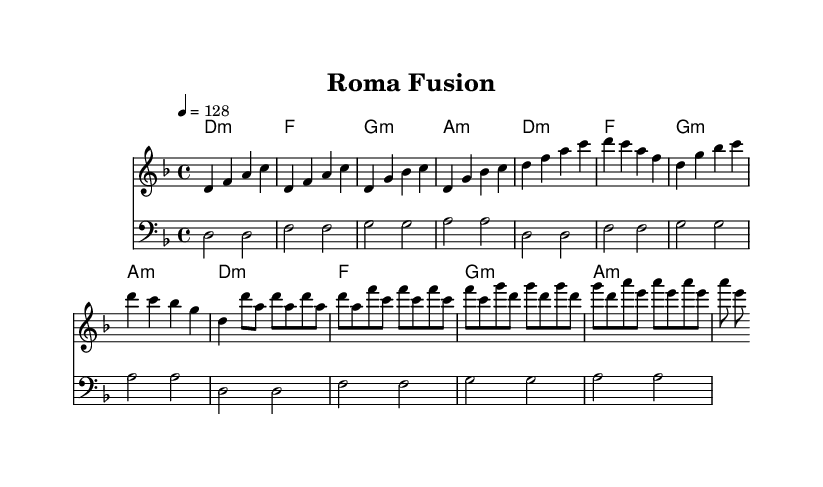What is the key signature of this music? The key signature is D minor, which has one flat (B flat).
Answer: D minor What is the time signature of the piece? The time signature is 4/4, indicating four beats per measure with a quarter note receiving one beat.
Answer: 4/4 What is the tempo marking of this piece? The tempo marking indicates that the piece should be played at 128 beats per minute, which is a moderate pace suitable for house music.
Answer: 128 How many measures are in the melody section? By counting the measures in the melody part, there are a total of 12 measures presented before it repeats, including the intro and verses.
Answer: 12 What is the harmonic structure of the piece? The harmonies follow a repeated progression with a sequence of minor and major chords, specifically yielding a pattern of D minor, F major, G minor, and A minor throughout.
Answer: D minor, F, G minor, A minor What rhythmic pattern is dominant in the drop section? The drop section primarily features eighth notes, creating an energetic driving force typical in progressive house music.
Answer: Eighth notes What musical influences are incorporated in this composition? The composition incorporates Roma traditions, identifiable through the melodic lines and rhythmic elements reflective of Romani music, layered with house beats and harmonies.
Answer: Roma traditions 